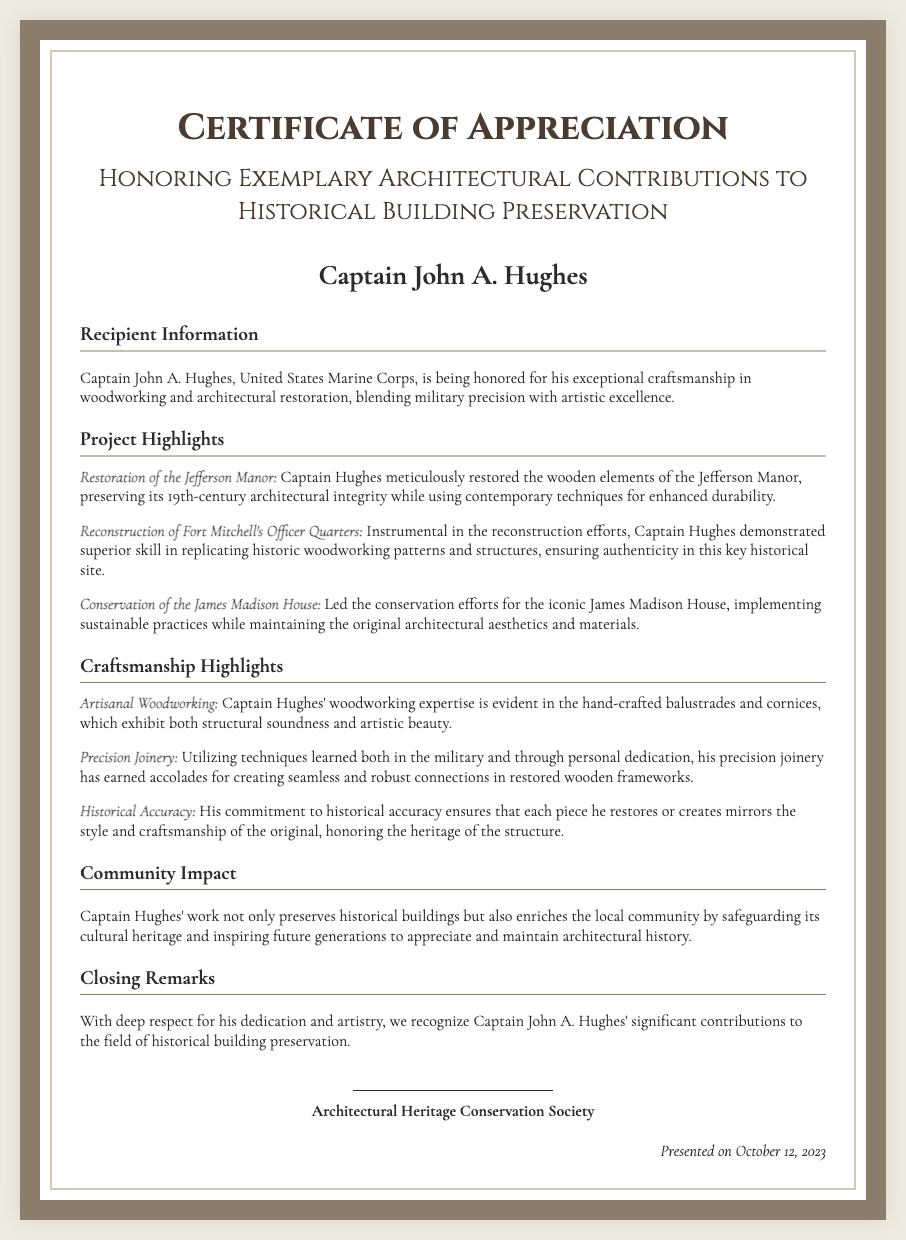What is the title of the certificate? The title of the certificate is prominently displayed at the top of the document.
Answer: Certificate of Appreciation Who is the recipient of the certificate? The recipient's name is clearly mentioned in a designated area on the certificate.
Answer: Captain John A. Hughes What date was the certificate presented? The presentation date is specifically noted towards the bottom of the document.
Answer: October 12, 2023 Which project involved the restoration of wooden elements? One of the projects highlighted focuses on restoring wooden elements of a specific building.
Answer: Restoration of the Jefferson Manor What organization issued the certificate? The issuer's name is included at the bottom of the certificate.
Answer: Architectural Heritage Conservation Society What is one highlight of Captain Hughes' craftsmanship? The document outlines several specific achievements, one of which can be directly quoted.
Answer: Artisanal Woodworking How does Captain Hughes impact the community? The text details the influence of Captain Hughes' work on the local area.
Answer: Safeguarding its cultural heritage How many key projects are mentioned in the document? The document lists several projects with specific achievements; counting them provides the total.
Answer: Three 